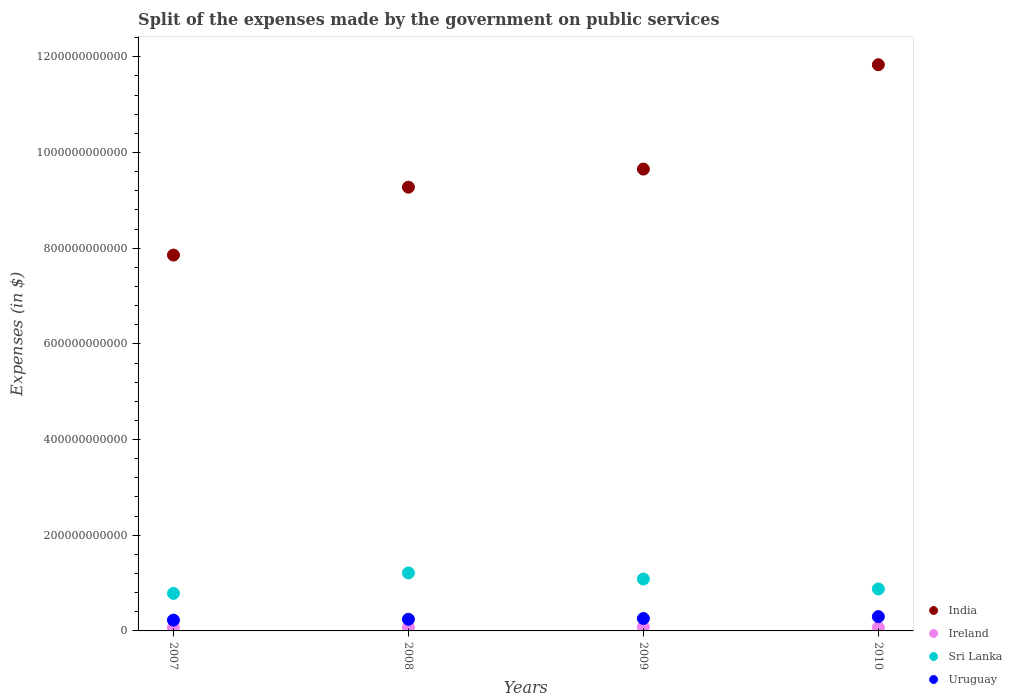How many different coloured dotlines are there?
Make the answer very short. 4. Is the number of dotlines equal to the number of legend labels?
Keep it short and to the point. Yes. What is the expenses made by the government on public services in Sri Lanka in 2008?
Make the answer very short. 1.21e+11. Across all years, what is the maximum expenses made by the government on public services in Sri Lanka?
Provide a short and direct response. 1.21e+11. Across all years, what is the minimum expenses made by the government on public services in Ireland?
Your response must be concise. 7.05e+09. In which year was the expenses made by the government on public services in Sri Lanka maximum?
Your answer should be compact. 2008. What is the total expenses made by the government on public services in Sri Lanka in the graph?
Provide a succinct answer. 3.96e+11. What is the difference between the expenses made by the government on public services in Uruguay in 2008 and that in 2009?
Provide a succinct answer. -1.56e+09. What is the difference between the expenses made by the government on public services in Sri Lanka in 2007 and the expenses made by the government on public services in Ireland in 2008?
Your answer should be very brief. 7.09e+1. What is the average expenses made by the government on public services in Ireland per year?
Offer a very short reply. 7.46e+09. In the year 2009, what is the difference between the expenses made by the government on public services in Uruguay and expenses made by the government on public services in Ireland?
Keep it short and to the point. 1.80e+1. In how many years, is the expenses made by the government on public services in Ireland greater than 1200000000000 $?
Provide a succinct answer. 0. What is the ratio of the expenses made by the government on public services in India in 2007 to that in 2008?
Offer a very short reply. 0.85. Is the expenses made by the government on public services in Ireland in 2007 less than that in 2010?
Your answer should be compact. No. Is the difference between the expenses made by the government on public services in Uruguay in 2008 and 2010 greater than the difference between the expenses made by the government on public services in Ireland in 2008 and 2010?
Offer a very short reply. No. What is the difference between the highest and the second highest expenses made by the government on public services in India?
Provide a short and direct response. 2.18e+11. What is the difference between the highest and the lowest expenses made by the government on public services in Uruguay?
Make the answer very short. 7.29e+09. Does the expenses made by the government on public services in Sri Lanka monotonically increase over the years?
Your answer should be compact. No. Is the expenses made by the government on public services in Sri Lanka strictly less than the expenses made by the government on public services in India over the years?
Keep it short and to the point. Yes. What is the difference between two consecutive major ticks on the Y-axis?
Your response must be concise. 2.00e+11. How many legend labels are there?
Provide a short and direct response. 4. How are the legend labels stacked?
Your answer should be very brief. Vertical. What is the title of the graph?
Your response must be concise. Split of the expenses made by the government on public services. Does "Germany" appear as one of the legend labels in the graph?
Ensure brevity in your answer.  No. What is the label or title of the Y-axis?
Make the answer very short. Expenses (in $). What is the Expenses (in $) of India in 2007?
Provide a succinct answer. 7.86e+11. What is the Expenses (in $) of Ireland in 2007?
Offer a very short reply. 7.32e+09. What is the Expenses (in $) of Sri Lanka in 2007?
Keep it short and to the point. 7.85e+1. What is the Expenses (in $) in Uruguay in 2007?
Ensure brevity in your answer.  2.26e+1. What is the Expenses (in $) of India in 2008?
Give a very brief answer. 9.28e+11. What is the Expenses (in $) of Ireland in 2008?
Make the answer very short. 7.59e+09. What is the Expenses (in $) in Sri Lanka in 2008?
Give a very brief answer. 1.21e+11. What is the Expenses (in $) in Uruguay in 2008?
Give a very brief answer. 2.44e+1. What is the Expenses (in $) in India in 2009?
Ensure brevity in your answer.  9.65e+11. What is the Expenses (in $) of Ireland in 2009?
Give a very brief answer. 7.87e+09. What is the Expenses (in $) in Sri Lanka in 2009?
Make the answer very short. 1.09e+11. What is the Expenses (in $) in Uruguay in 2009?
Your response must be concise. 2.59e+1. What is the Expenses (in $) of India in 2010?
Your response must be concise. 1.18e+12. What is the Expenses (in $) of Ireland in 2010?
Your response must be concise. 7.05e+09. What is the Expenses (in $) of Sri Lanka in 2010?
Ensure brevity in your answer.  8.77e+1. What is the Expenses (in $) of Uruguay in 2010?
Ensure brevity in your answer.  2.99e+1. Across all years, what is the maximum Expenses (in $) of India?
Your answer should be very brief. 1.18e+12. Across all years, what is the maximum Expenses (in $) in Ireland?
Make the answer very short. 7.87e+09. Across all years, what is the maximum Expenses (in $) in Sri Lanka?
Offer a terse response. 1.21e+11. Across all years, what is the maximum Expenses (in $) in Uruguay?
Your answer should be compact. 2.99e+1. Across all years, what is the minimum Expenses (in $) of India?
Give a very brief answer. 7.86e+11. Across all years, what is the minimum Expenses (in $) in Ireland?
Provide a succinct answer. 7.05e+09. Across all years, what is the minimum Expenses (in $) of Sri Lanka?
Give a very brief answer. 7.85e+1. Across all years, what is the minimum Expenses (in $) in Uruguay?
Ensure brevity in your answer.  2.26e+1. What is the total Expenses (in $) of India in the graph?
Your response must be concise. 3.86e+12. What is the total Expenses (in $) of Ireland in the graph?
Keep it short and to the point. 2.98e+1. What is the total Expenses (in $) in Sri Lanka in the graph?
Make the answer very short. 3.96e+11. What is the total Expenses (in $) in Uruguay in the graph?
Your answer should be very brief. 1.03e+11. What is the difference between the Expenses (in $) of India in 2007 and that in 2008?
Your answer should be very brief. -1.42e+11. What is the difference between the Expenses (in $) of Ireland in 2007 and that in 2008?
Your answer should be very brief. -2.67e+08. What is the difference between the Expenses (in $) of Sri Lanka in 2007 and that in 2008?
Keep it short and to the point. -4.28e+1. What is the difference between the Expenses (in $) of Uruguay in 2007 and that in 2008?
Ensure brevity in your answer.  -1.78e+09. What is the difference between the Expenses (in $) in India in 2007 and that in 2009?
Your answer should be very brief. -1.80e+11. What is the difference between the Expenses (in $) in Ireland in 2007 and that in 2009?
Offer a very short reply. -5.46e+08. What is the difference between the Expenses (in $) in Sri Lanka in 2007 and that in 2009?
Provide a short and direct response. -3.00e+1. What is the difference between the Expenses (in $) of Uruguay in 2007 and that in 2009?
Your response must be concise. -3.34e+09. What is the difference between the Expenses (in $) in India in 2007 and that in 2010?
Provide a short and direct response. -3.98e+11. What is the difference between the Expenses (in $) in Ireland in 2007 and that in 2010?
Offer a terse response. 2.69e+08. What is the difference between the Expenses (in $) in Sri Lanka in 2007 and that in 2010?
Give a very brief answer. -9.26e+09. What is the difference between the Expenses (in $) in Uruguay in 2007 and that in 2010?
Offer a very short reply. -7.29e+09. What is the difference between the Expenses (in $) of India in 2008 and that in 2009?
Offer a terse response. -3.78e+1. What is the difference between the Expenses (in $) of Ireland in 2008 and that in 2009?
Provide a succinct answer. -2.79e+08. What is the difference between the Expenses (in $) of Sri Lanka in 2008 and that in 2009?
Offer a very short reply. 1.27e+1. What is the difference between the Expenses (in $) in Uruguay in 2008 and that in 2009?
Your answer should be very brief. -1.56e+09. What is the difference between the Expenses (in $) in India in 2008 and that in 2010?
Ensure brevity in your answer.  -2.56e+11. What is the difference between the Expenses (in $) in Ireland in 2008 and that in 2010?
Ensure brevity in your answer.  5.35e+08. What is the difference between the Expenses (in $) in Sri Lanka in 2008 and that in 2010?
Offer a terse response. 3.35e+1. What is the difference between the Expenses (in $) in Uruguay in 2008 and that in 2010?
Provide a succinct answer. -5.50e+09. What is the difference between the Expenses (in $) in India in 2009 and that in 2010?
Ensure brevity in your answer.  -2.18e+11. What is the difference between the Expenses (in $) of Ireland in 2009 and that in 2010?
Make the answer very short. 8.15e+08. What is the difference between the Expenses (in $) in Sri Lanka in 2009 and that in 2010?
Keep it short and to the point. 2.08e+1. What is the difference between the Expenses (in $) in Uruguay in 2009 and that in 2010?
Keep it short and to the point. -3.95e+09. What is the difference between the Expenses (in $) of India in 2007 and the Expenses (in $) of Ireland in 2008?
Your response must be concise. 7.78e+11. What is the difference between the Expenses (in $) of India in 2007 and the Expenses (in $) of Sri Lanka in 2008?
Keep it short and to the point. 6.64e+11. What is the difference between the Expenses (in $) of India in 2007 and the Expenses (in $) of Uruguay in 2008?
Your response must be concise. 7.61e+11. What is the difference between the Expenses (in $) of Ireland in 2007 and the Expenses (in $) of Sri Lanka in 2008?
Your answer should be compact. -1.14e+11. What is the difference between the Expenses (in $) of Ireland in 2007 and the Expenses (in $) of Uruguay in 2008?
Your response must be concise. -1.70e+1. What is the difference between the Expenses (in $) of Sri Lanka in 2007 and the Expenses (in $) of Uruguay in 2008?
Your response must be concise. 5.41e+1. What is the difference between the Expenses (in $) in India in 2007 and the Expenses (in $) in Ireland in 2009?
Provide a short and direct response. 7.78e+11. What is the difference between the Expenses (in $) in India in 2007 and the Expenses (in $) in Sri Lanka in 2009?
Provide a short and direct response. 6.77e+11. What is the difference between the Expenses (in $) of India in 2007 and the Expenses (in $) of Uruguay in 2009?
Your answer should be very brief. 7.60e+11. What is the difference between the Expenses (in $) of Ireland in 2007 and the Expenses (in $) of Sri Lanka in 2009?
Your answer should be compact. -1.01e+11. What is the difference between the Expenses (in $) in Ireland in 2007 and the Expenses (in $) in Uruguay in 2009?
Offer a terse response. -1.86e+1. What is the difference between the Expenses (in $) of Sri Lanka in 2007 and the Expenses (in $) of Uruguay in 2009?
Give a very brief answer. 5.26e+1. What is the difference between the Expenses (in $) of India in 2007 and the Expenses (in $) of Ireland in 2010?
Provide a short and direct response. 7.79e+11. What is the difference between the Expenses (in $) of India in 2007 and the Expenses (in $) of Sri Lanka in 2010?
Offer a very short reply. 6.98e+11. What is the difference between the Expenses (in $) in India in 2007 and the Expenses (in $) in Uruguay in 2010?
Your answer should be very brief. 7.56e+11. What is the difference between the Expenses (in $) in Ireland in 2007 and the Expenses (in $) in Sri Lanka in 2010?
Ensure brevity in your answer.  -8.04e+1. What is the difference between the Expenses (in $) of Ireland in 2007 and the Expenses (in $) of Uruguay in 2010?
Offer a terse response. -2.25e+1. What is the difference between the Expenses (in $) in Sri Lanka in 2007 and the Expenses (in $) in Uruguay in 2010?
Ensure brevity in your answer.  4.86e+1. What is the difference between the Expenses (in $) of India in 2008 and the Expenses (in $) of Ireland in 2009?
Ensure brevity in your answer.  9.20e+11. What is the difference between the Expenses (in $) of India in 2008 and the Expenses (in $) of Sri Lanka in 2009?
Make the answer very short. 8.19e+11. What is the difference between the Expenses (in $) in India in 2008 and the Expenses (in $) in Uruguay in 2009?
Your response must be concise. 9.02e+11. What is the difference between the Expenses (in $) of Ireland in 2008 and the Expenses (in $) of Sri Lanka in 2009?
Offer a terse response. -1.01e+11. What is the difference between the Expenses (in $) in Ireland in 2008 and the Expenses (in $) in Uruguay in 2009?
Keep it short and to the point. -1.83e+1. What is the difference between the Expenses (in $) of Sri Lanka in 2008 and the Expenses (in $) of Uruguay in 2009?
Ensure brevity in your answer.  9.53e+1. What is the difference between the Expenses (in $) in India in 2008 and the Expenses (in $) in Ireland in 2010?
Make the answer very short. 9.20e+11. What is the difference between the Expenses (in $) of India in 2008 and the Expenses (in $) of Sri Lanka in 2010?
Your answer should be very brief. 8.40e+11. What is the difference between the Expenses (in $) of India in 2008 and the Expenses (in $) of Uruguay in 2010?
Give a very brief answer. 8.98e+11. What is the difference between the Expenses (in $) in Ireland in 2008 and the Expenses (in $) in Sri Lanka in 2010?
Offer a very short reply. -8.01e+1. What is the difference between the Expenses (in $) in Ireland in 2008 and the Expenses (in $) in Uruguay in 2010?
Make the answer very short. -2.23e+1. What is the difference between the Expenses (in $) in Sri Lanka in 2008 and the Expenses (in $) in Uruguay in 2010?
Give a very brief answer. 9.14e+1. What is the difference between the Expenses (in $) in India in 2009 and the Expenses (in $) in Ireland in 2010?
Make the answer very short. 9.58e+11. What is the difference between the Expenses (in $) in India in 2009 and the Expenses (in $) in Sri Lanka in 2010?
Ensure brevity in your answer.  8.78e+11. What is the difference between the Expenses (in $) in India in 2009 and the Expenses (in $) in Uruguay in 2010?
Ensure brevity in your answer.  9.36e+11. What is the difference between the Expenses (in $) of Ireland in 2009 and the Expenses (in $) of Sri Lanka in 2010?
Your answer should be compact. -7.99e+1. What is the difference between the Expenses (in $) of Ireland in 2009 and the Expenses (in $) of Uruguay in 2010?
Your answer should be compact. -2.20e+1. What is the difference between the Expenses (in $) of Sri Lanka in 2009 and the Expenses (in $) of Uruguay in 2010?
Provide a short and direct response. 7.86e+1. What is the average Expenses (in $) in India per year?
Your answer should be very brief. 9.65e+11. What is the average Expenses (in $) of Ireland per year?
Keep it short and to the point. 7.46e+09. What is the average Expenses (in $) in Sri Lanka per year?
Provide a succinct answer. 9.90e+1. What is the average Expenses (in $) of Uruguay per year?
Your answer should be compact. 2.57e+1. In the year 2007, what is the difference between the Expenses (in $) in India and Expenses (in $) in Ireland?
Offer a terse response. 7.78e+11. In the year 2007, what is the difference between the Expenses (in $) in India and Expenses (in $) in Sri Lanka?
Provide a succinct answer. 7.07e+11. In the year 2007, what is the difference between the Expenses (in $) in India and Expenses (in $) in Uruguay?
Your answer should be very brief. 7.63e+11. In the year 2007, what is the difference between the Expenses (in $) in Ireland and Expenses (in $) in Sri Lanka?
Your answer should be compact. -7.12e+1. In the year 2007, what is the difference between the Expenses (in $) of Ireland and Expenses (in $) of Uruguay?
Offer a terse response. -1.53e+1. In the year 2007, what is the difference between the Expenses (in $) in Sri Lanka and Expenses (in $) in Uruguay?
Provide a succinct answer. 5.59e+1. In the year 2008, what is the difference between the Expenses (in $) in India and Expenses (in $) in Ireland?
Give a very brief answer. 9.20e+11. In the year 2008, what is the difference between the Expenses (in $) of India and Expenses (in $) of Sri Lanka?
Offer a very short reply. 8.06e+11. In the year 2008, what is the difference between the Expenses (in $) in India and Expenses (in $) in Uruguay?
Offer a terse response. 9.03e+11. In the year 2008, what is the difference between the Expenses (in $) in Ireland and Expenses (in $) in Sri Lanka?
Offer a very short reply. -1.14e+11. In the year 2008, what is the difference between the Expenses (in $) in Ireland and Expenses (in $) in Uruguay?
Provide a short and direct response. -1.68e+1. In the year 2008, what is the difference between the Expenses (in $) in Sri Lanka and Expenses (in $) in Uruguay?
Give a very brief answer. 9.69e+1. In the year 2009, what is the difference between the Expenses (in $) in India and Expenses (in $) in Ireland?
Provide a short and direct response. 9.58e+11. In the year 2009, what is the difference between the Expenses (in $) of India and Expenses (in $) of Sri Lanka?
Offer a very short reply. 8.57e+11. In the year 2009, what is the difference between the Expenses (in $) of India and Expenses (in $) of Uruguay?
Provide a short and direct response. 9.39e+11. In the year 2009, what is the difference between the Expenses (in $) in Ireland and Expenses (in $) in Sri Lanka?
Ensure brevity in your answer.  -1.01e+11. In the year 2009, what is the difference between the Expenses (in $) in Ireland and Expenses (in $) in Uruguay?
Provide a succinct answer. -1.80e+1. In the year 2009, what is the difference between the Expenses (in $) of Sri Lanka and Expenses (in $) of Uruguay?
Offer a very short reply. 8.26e+1. In the year 2010, what is the difference between the Expenses (in $) in India and Expenses (in $) in Ireland?
Provide a short and direct response. 1.18e+12. In the year 2010, what is the difference between the Expenses (in $) of India and Expenses (in $) of Sri Lanka?
Give a very brief answer. 1.10e+12. In the year 2010, what is the difference between the Expenses (in $) of India and Expenses (in $) of Uruguay?
Provide a succinct answer. 1.15e+12. In the year 2010, what is the difference between the Expenses (in $) in Ireland and Expenses (in $) in Sri Lanka?
Your answer should be very brief. -8.07e+1. In the year 2010, what is the difference between the Expenses (in $) in Ireland and Expenses (in $) in Uruguay?
Give a very brief answer. -2.28e+1. In the year 2010, what is the difference between the Expenses (in $) in Sri Lanka and Expenses (in $) in Uruguay?
Ensure brevity in your answer.  5.79e+1. What is the ratio of the Expenses (in $) in India in 2007 to that in 2008?
Provide a succinct answer. 0.85. What is the ratio of the Expenses (in $) in Ireland in 2007 to that in 2008?
Make the answer very short. 0.96. What is the ratio of the Expenses (in $) in Sri Lanka in 2007 to that in 2008?
Keep it short and to the point. 0.65. What is the ratio of the Expenses (in $) in Uruguay in 2007 to that in 2008?
Your answer should be very brief. 0.93. What is the ratio of the Expenses (in $) in India in 2007 to that in 2009?
Your answer should be compact. 0.81. What is the ratio of the Expenses (in $) in Ireland in 2007 to that in 2009?
Provide a short and direct response. 0.93. What is the ratio of the Expenses (in $) of Sri Lanka in 2007 to that in 2009?
Your answer should be very brief. 0.72. What is the ratio of the Expenses (in $) in Uruguay in 2007 to that in 2009?
Provide a short and direct response. 0.87. What is the ratio of the Expenses (in $) of India in 2007 to that in 2010?
Give a very brief answer. 0.66. What is the ratio of the Expenses (in $) in Ireland in 2007 to that in 2010?
Offer a terse response. 1.04. What is the ratio of the Expenses (in $) of Sri Lanka in 2007 to that in 2010?
Provide a short and direct response. 0.89. What is the ratio of the Expenses (in $) of Uruguay in 2007 to that in 2010?
Ensure brevity in your answer.  0.76. What is the ratio of the Expenses (in $) of India in 2008 to that in 2009?
Make the answer very short. 0.96. What is the ratio of the Expenses (in $) in Ireland in 2008 to that in 2009?
Your answer should be compact. 0.96. What is the ratio of the Expenses (in $) in Sri Lanka in 2008 to that in 2009?
Ensure brevity in your answer.  1.12. What is the ratio of the Expenses (in $) in Uruguay in 2008 to that in 2009?
Your answer should be compact. 0.94. What is the ratio of the Expenses (in $) of India in 2008 to that in 2010?
Provide a succinct answer. 0.78. What is the ratio of the Expenses (in $) of Ireland in 2008 to that in 2010?
Make the answer very short. 1.08. What is the ratio of the Expenses (in $) of Sri Lanka in 2008 to that in 2010?
Keep it short and to the point. 1.38. What is the ratio of the Expenses (in $) of Uruguay in 2008 to that in 2010?
Keep it short and to the point. 0.82. What is the ratio of the Expenses (in $) in India in 2009 to that in 2010?
Offer a very short reply. 0.82. What is the ratio of the Expenses (in $) in Ireland in 2009 to that in 2010?
Provide a short and direct response. 1.12. What is the ratio of the Expenses (in $) in Sri Lanka in 2009 to that in 2010?
Make the answer very short. 1.24. What is the ratio of the Expenses (in $) of Uruguay in 2009 to that in 2010?
Make the answer very short. 0.87. What is the difference between the highest and the second highest Expenses (in $) in India?
Your response must be concise. 2.18e+11. What is the difference between the highest and the second highest Expenses (in $) in Ireland?
Your response must be concise. 2.79e+08. What is the difference between the highest and the second highest Expenses (in $) in Sri Lanka?
Your answer should be compact. 1.27e+1. What is the difference between the highest and the second highest Expenses (in $) in Uruguay?
Keep it short and to the point. 3.95e+09. What is the difference between the highest and the lowest Expenses (in $) in India?
Provide a succinct answer. 3.98e+11. What is the difference between the highest and the lowest Expenses (in $) in Ireland?
Your answer should be compact. 8.15e+08. What is the difference between the highest and the lowest Expenses (in $) in Sri Lanka?
Provide a short and direct response. 4.28e+1. What is the difference between the highest and the lowest Expenses (in $) in Uruguay?
Keep it short and to the point. 7.29e+09. 